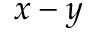Convert formula to latex. <formula><loc_0><loc_0><loc_500><loc_500>x - y</formula> 